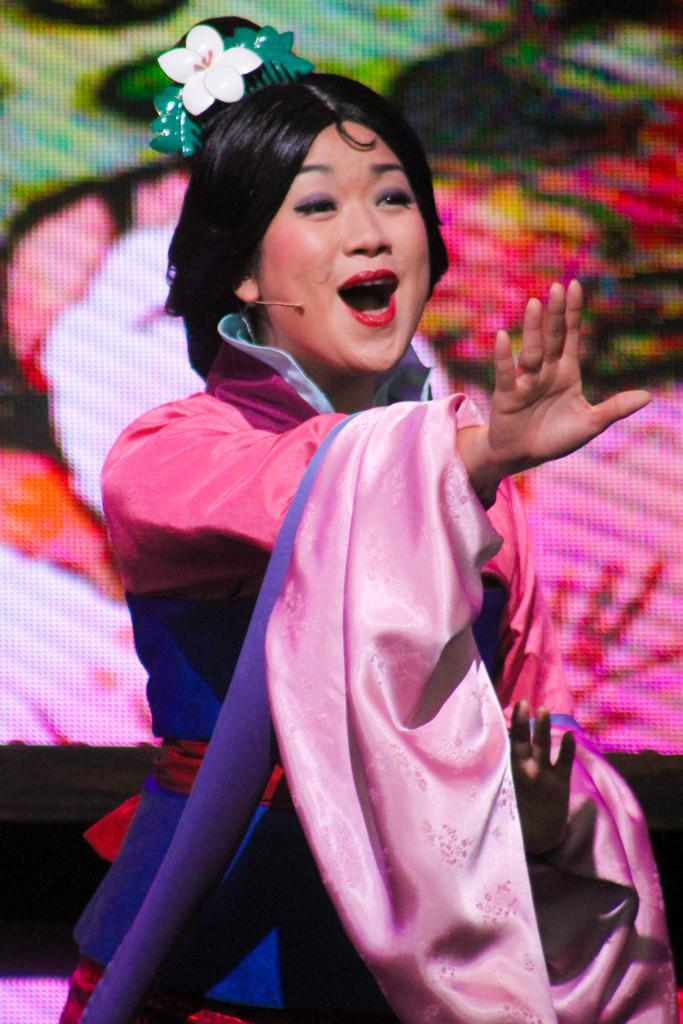Who is present in the image? There is a woman in the image. What can be observed about the background of the image? The background of the image is blurry. What type of cake is being selected by the woman in the image? There is no cake or selection process depicted in the image; it only features a woman with a blurry background. 